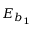Convert formula to latex. <formula><loc_0><loc_0><loc_500><loc_500>E _ { b _ { 1 } }</formula> 